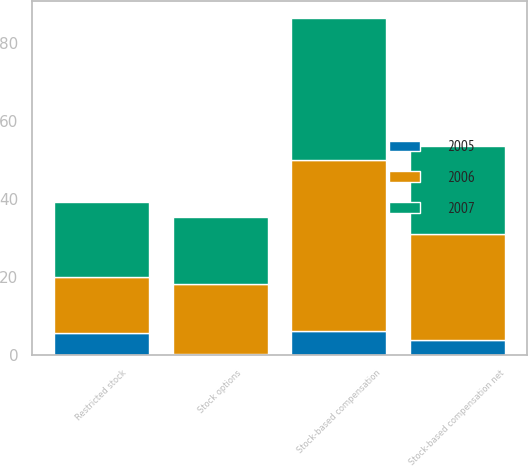Convert chart. <chart><loc_0><loc_0><loc_500><loc_500><stacked_bar_chart><ecel><fcel>Stock options<fcel>Restricted stock<fcel>Stock-based compensation<fcel>Stock-based compensation net<nl><fcel>2007<fcel>17.2<fcel>19.2<fcel>36.4<fcel>22.6<nl><fcel>2006<fcel>17.8<fcel>14.3<fcel>44<fcel>27.3<nl><fcel>2005<fcel>0.4<fcel>5.7<fcel>6.1<fcel>3.8<nl></chart> 